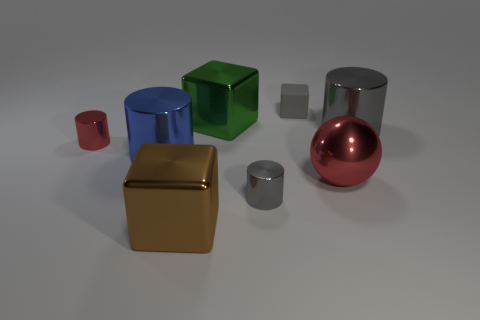Add 2 spheres. How many objects exist? 10 Subtract all balls. How many objects are left? 7 Add 2 large metallic cylinders. How many large metallic cylinders are left? 4 Add 4 large red cylinders. How many large red cylinders exist? 4 Subtract 0 cyan cylinders. How many objects are left? 8 Subtract all red metal cylinders. Subtract all small red objects. How many objects are left? 6 